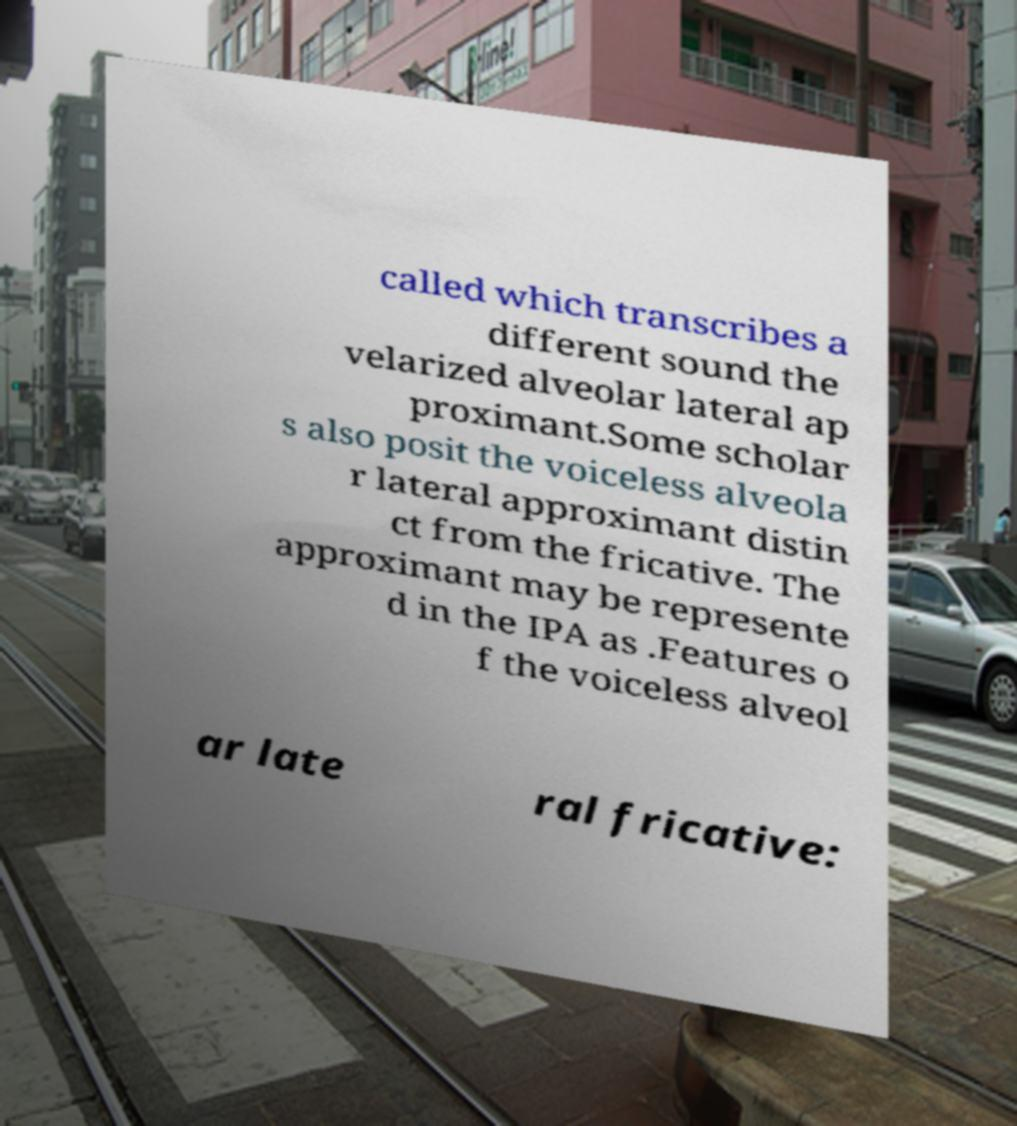There's text embedded in this image that I need extracted. Can you transcribe it verbatim? called which transcribes a different sound the velarized alveolar lateral ap proximant.Some scholar s also posit the voiceless alveola r lateral approximant distin ct from the fricative. The approximant may be represente d in the IPA as .Features o f the voiceless alveol ar late ral fricative: 